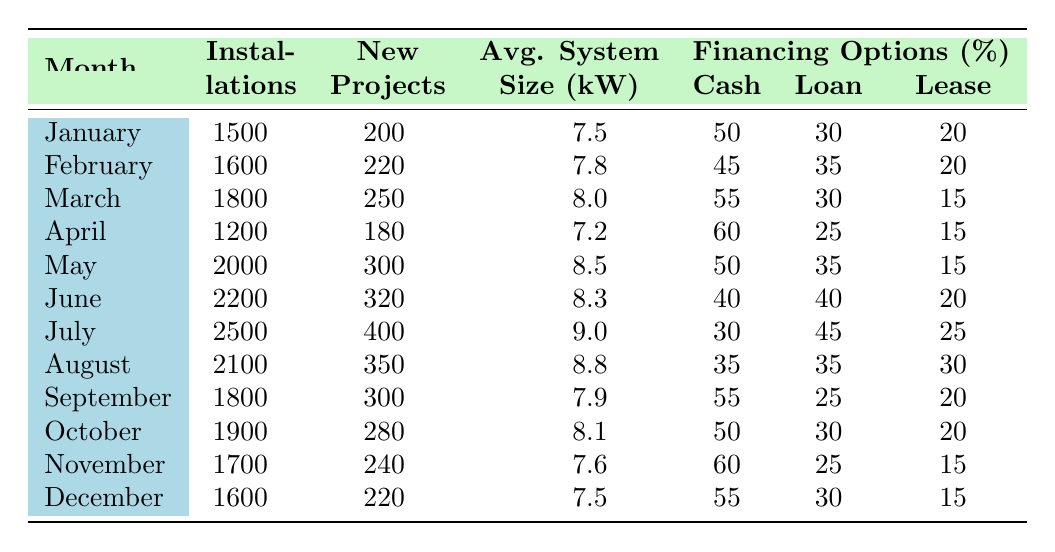What month saw the highest number of solar panel installations? By examining the "Installations" column across all months, July has the highest number at 2500.
Answer: July In which month was the average system size the largest? Looking at the "Average System Size (kW)" column, July has the highest value at 9.0 kW.
Answer: July How many solar panel installations were there in the first half of the year (January to June)? Summing the installations for January (1500), February (1600), March (1800), April (1200), May (2000), and June (2200) gives 1500 + 1600 + 1800 + 1200 + 2000 + 2200 = 11300 installations.
Answer: 11300 What percentage of financing options involved loan financing in March? In March, the table indicates that 30% of financing options were through loan financing.
Answer: 30 Was there a month with a greater number of new projects than installations? Reviewing the "New Projects" and "Installations" columns, all months have more installations than new projects, so the answer is no.
Answer: No What is the average percentage of cash purchases across all months? The percentages of cash purchases are: 50, 45, 55, 60, 50, 40, 30, 35, 55, 50, 60, 55. The average is (50 + 45 + 55 + 60 + 50 + 40 + 30 + 35 + 55 + 50 + 60 + 55) / 12 = 47.5%.
Answer: 47.5 What was the trend in installations from May to July? May had 2000 installations, June had 2200, and July had 2500, indicating an increasing trend over these months.
Answer: Increasing Which month had the lowest number of new projects and what was the value? Looking at the "New Projects" column, April had the lowest with 180 new projects.
Answer: April, 180 How many more installations were there in June compared to September? June had 2200 installations and September had 1800, so the difference is 2200 - 1800 = 400 installations more in June.
Answer: 400 